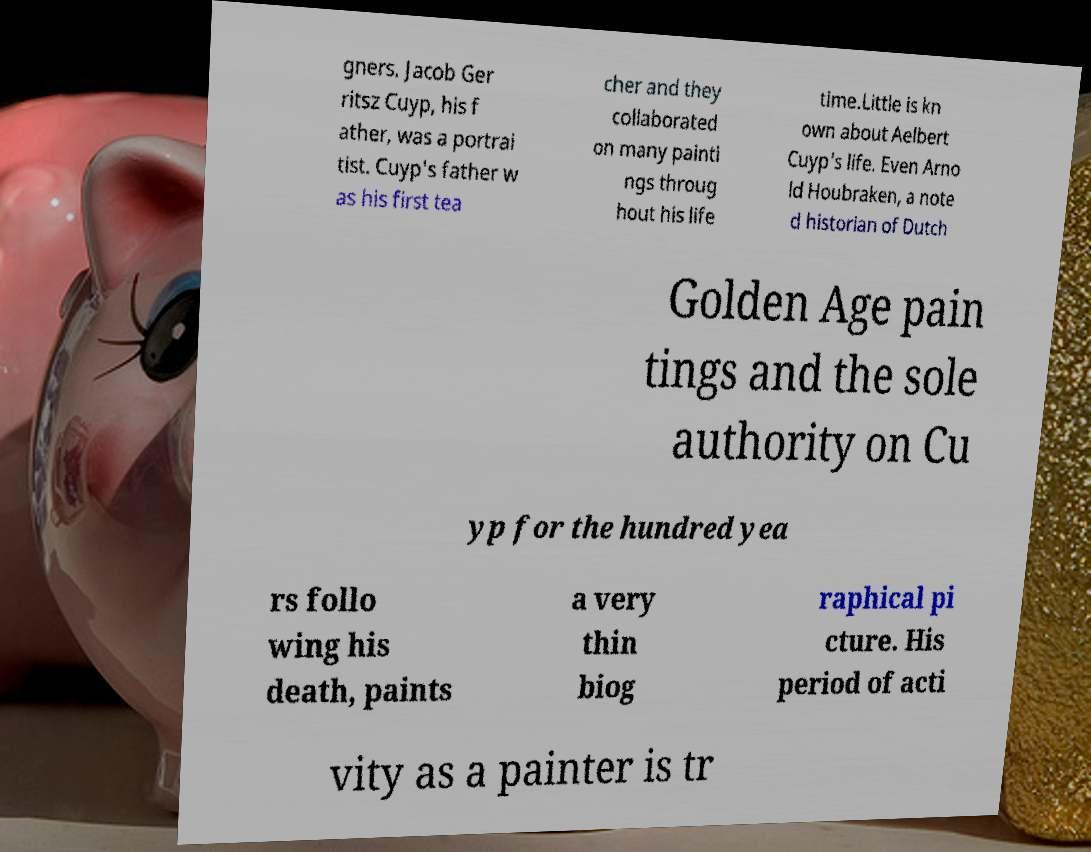I need the written content from this picture converted into text. Can you do that? gners. Jacob Ger ritsz Cuyp, his f ather, was a portrai tist. Cuyp's father w as his first tea cher and they collaborated on many painti ngs throug hout his life time.Little is kn own about Aelbert Cuyp's life. Even Arno ld Houbraken, a note d historian of Dutch Golden Age pain tings and the sole authority on Cu yp for the hundred yea rs follo wing his death, paints a very thin biog raphical pi cture. His period of acti vity as a painter is tr 